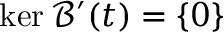Convert formula to latex. <formula><loc_0><loc_0><loc_500><loc_500>\ker \mathcal { B } ^ { \prime } ( t ) = \{ 0 \}</formula> 